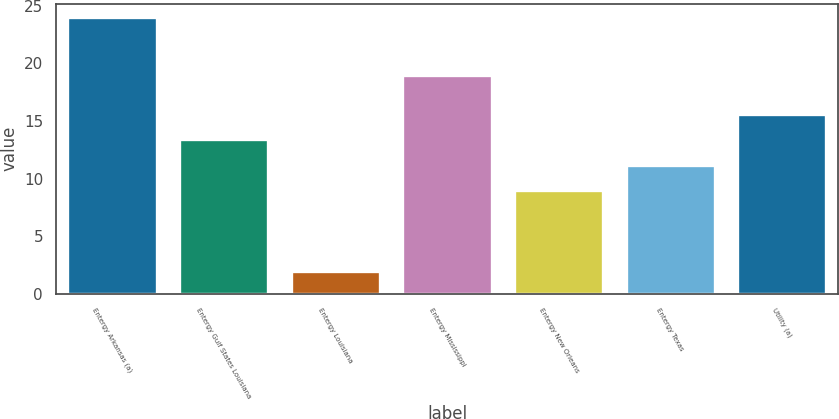Convert chart. <chart><loc_0><loc_0><loc_500><loc_500><bar_chart><fcel>Entergy Arkansas (a)<fcel>Entergy Gulf States Louisiana<fcel>Entergy Louisiana<fcel>Entergy Mississippi<fcel>Entergy New Orleans<fcel>Entergy Texas<fcel>Utility (a)<nl><fcel>24<fcel>13.4<fcel>2<fcel>19<fcel>9<fcel>11.2<fcel>15.6<nl></chart> 